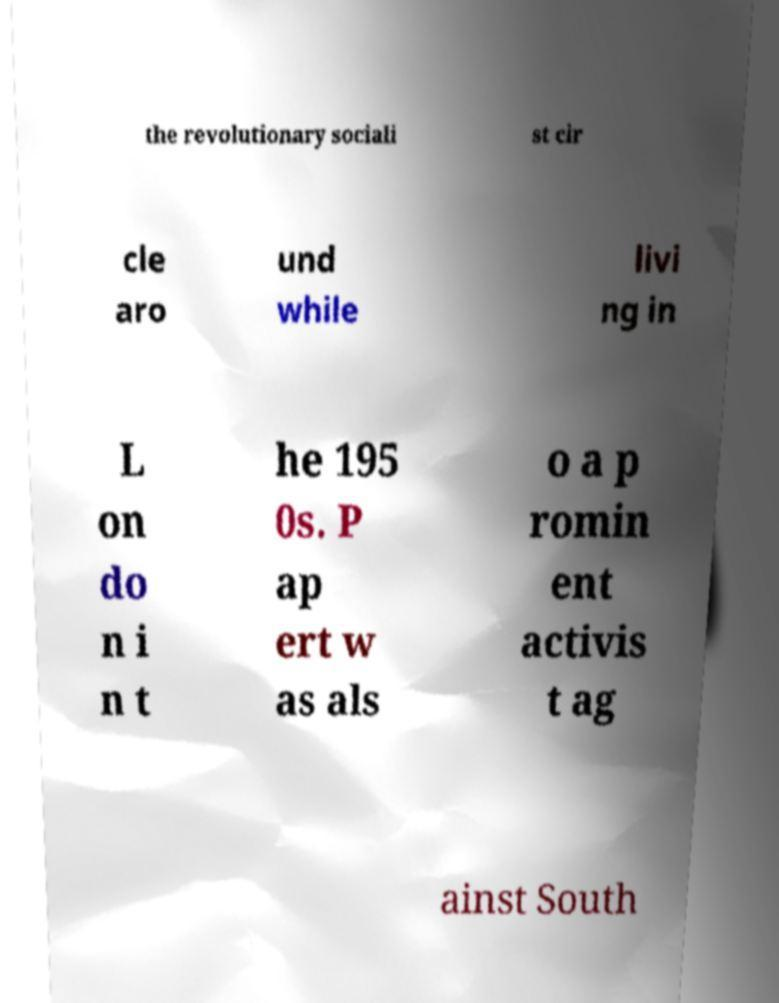For documentation purposes, I need the text within this image transcribed. Could you provide that? the revolutionary sociali st cir cle aro und while livi ng in L on do n i n t he 195 0s. P ap ert w as als o a p romin ent activis t ag ainst South 